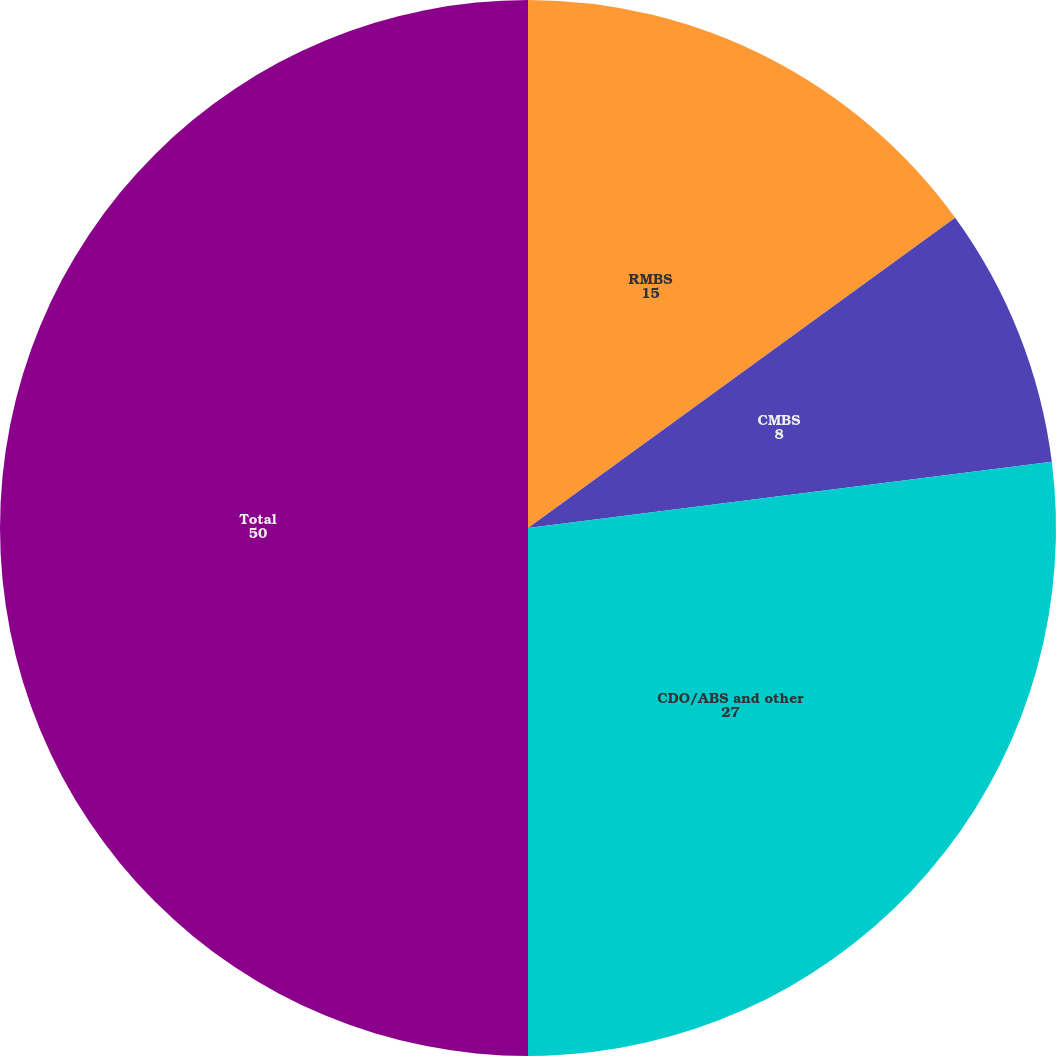Convert chart. <chart><loc_0><loc_0><loc_500><loc_500><pie_chart><fcel>RMBS<fcel>CMBS<fcel>CDO/ABS and other<fcel>Total<nl><fcel>15.0%<fcel>8.0%<fcel>27.0%<fcel>50.0%<nl></chart> 